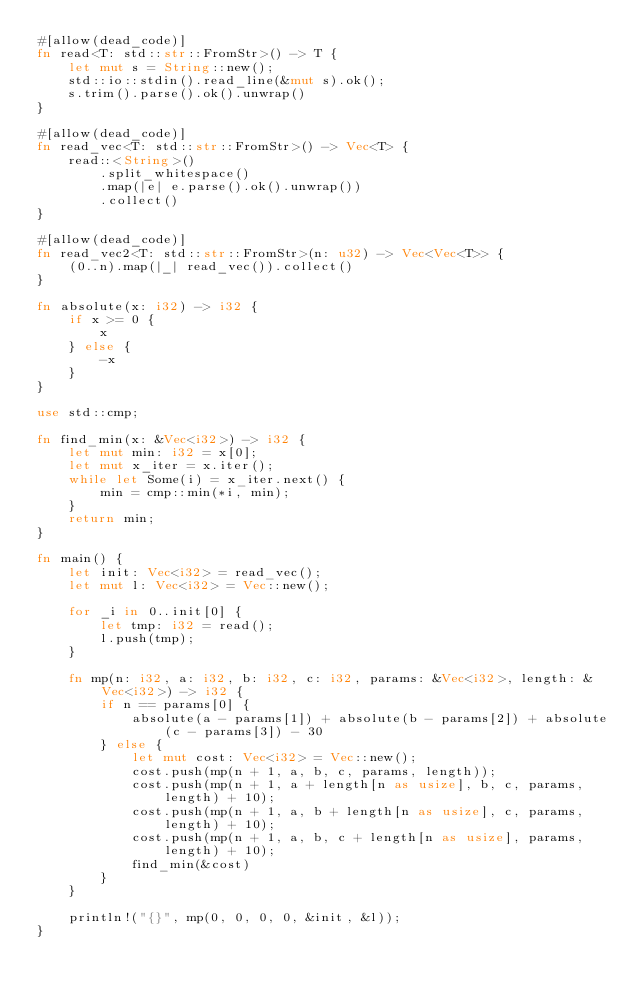<code> <loc_0><loc_0><loc_500><loc_500><_Rust_>#[allow(dead_code)]
fn read<T: std::str::FromStr>() -> T {
    let mut s = String::new();
    std::io::stdin().read_line(&mut s).ok();
    s.trim().parse().ok().unwrap()
}

#[allow(dead_code)]
fn read_vec<T: std::str::FromStr>() -> Vec<T> {
    read::<String>()
        .split_whitespace()
        .map(|e| e.parse().ok().unwrap())
        .collect()
}

#[allow(dead_code)]
fn read_vec2<T: std::str::FromStr>(n: u32) -> Vec<Vec<T>> {
    (0..n).map(|_| read_vec()).collect()
}

fn absolute(x: i32) -> i32 {
    if x >= 0 {
        x
    } else {
        -x
    }
}

use std::cmp;

fn find_min(x: &Vec<i32>) -> i32 {
    let mut min: i32 = x[0];
    let mut x_iter = x.iter();
    while let Some(i) = x_iter.next() {
        min = cmp::min(*i, min);
    }
    return min;
}

fn main() {
    let init: Vec<i32> = read_vec();
    let mut l: Vec<i32> = Vec::new();

    for _i in 0..init[0] {
        let tmp: i32 = read();
        l.push(tmp);
    }

    fn mp(n: i32, a: i32, b: i32, c: i32, params: &Vec<i32>, length: &Vec<i32>) -> i32 {
        if n == params[0] {
            absolute(a - params[1]) + absolute(b - params[2]) + absolute(c - params[3]) - 30
        } else {
            let mut cost: Vec<i32> = Vec::new();
            cost.push(mp(n + 1, a, b, c, params, length));
            cost.push(mp(n + 1, a + length[n as usize], b, c, params, length) + 10);
            cost.push(mp(n + 1, a, b + length[n as usize], c, params, length) + 10);
            cost.push(mp(n + 1, a, b, c + length[n as usize], params, length) + 10);
            find_min(&cost)
        }
    }

    println!("{}", mp(0, 0, 0, 0, &init, &l));
}
</code> 